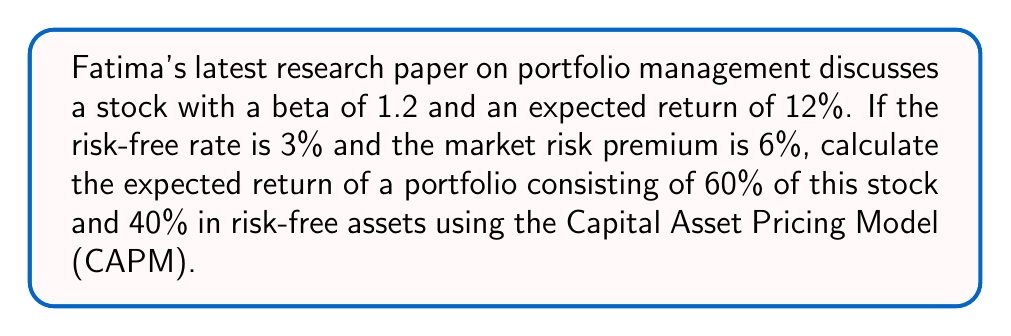Show me your answer to this math problem. To solve this problem, we'll use the Capital Asset Pricing Model (CAPM) and portfolio theory. Let's break it down step by step:

1. First, recall the CAPM formula:
   $$ E(R_i) = R_f + \beta_i(E(R_m) - R_f) $$
   where:
   $E(R_i)$ is the expected return of the asset
   $R_f$ is the risk-free rate
   $\beta_i$ is the beta of the asset
   $E(R_m) - R_f$ is the market risk premium

2. We're given:
   - Beta of the stock ($\beta_i$) = 1.2
   - Risk-free rate ($R_f$) = 3%
   - Market risk premium ($E(R_m) - R_f$) = 6%

3. Let's verify the expected return of the stock using CAPM:
   $$ E(R_i) = 3\% + 1.2(6\%) = 3\% + 7.2\% = 10.2\% $$

   Note: The given expected return of 12% is higher than the CAPM prediction, indicating potential alpha.

4. Now, let's calculate the expected return of the portfolio:
   - 60% in the stock
   - 40% in risk-free assets

   We can use the weighted average of returns:
   $$ E(R_p) = w_1 E(R_1) + w_2 E(R_2) $$
   where:
   $E(R_p)$ is the expected return of the portfolio
   $w_1$ and $w_2$ are the weights of each asset
   $E(R_1)$ and $E(R_2)$ are the expected returns of each asset

5. Plugging in the values:
   $$ E(R_p) = 0.6(12\%) + 0.4(3\%) $$
   $$ E(R_p) = 7.2\% + 1.2\% $$
   $$ E(R_p) = 8.4\% $$

Thus, the expected return of the portfolio is 8.4%.
Answer: The expected return of the portfolio is 8.4%. 